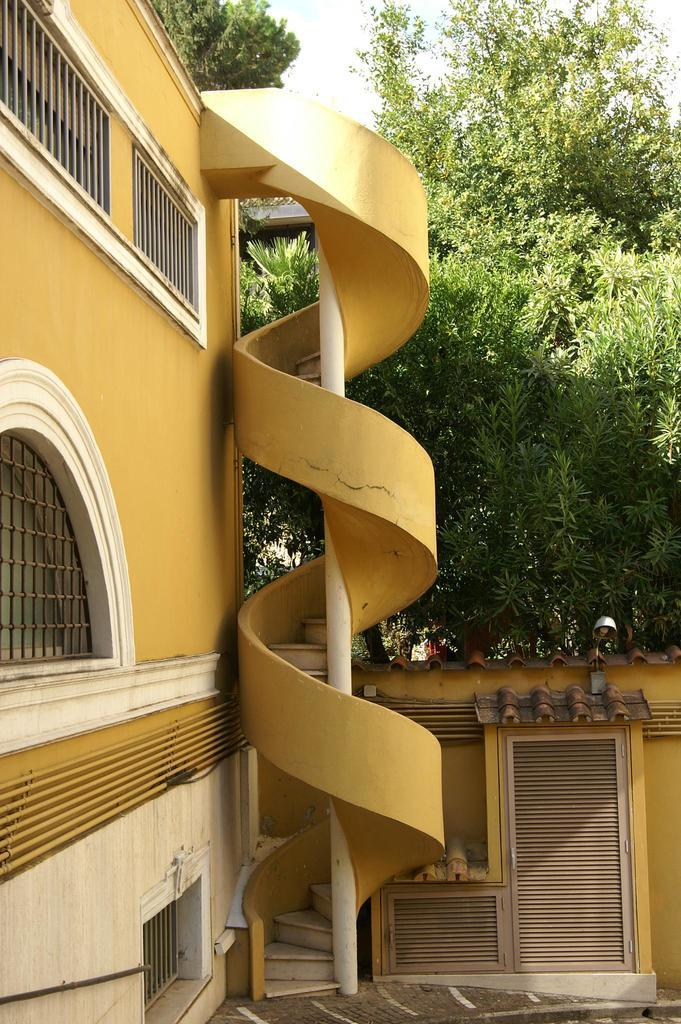What type of structure is present in the image? There is a building in the image. Can you describe the color of the building? The building is white and yellow in color. What can be seen in the background of the image? There are trees in the background of the image. What is the color of the sky in the image? The sky is white in the image. What type of creature is sitting on the clock in the image? There is no clock present in the image, and therefore no creature can be seen sitting on it. 